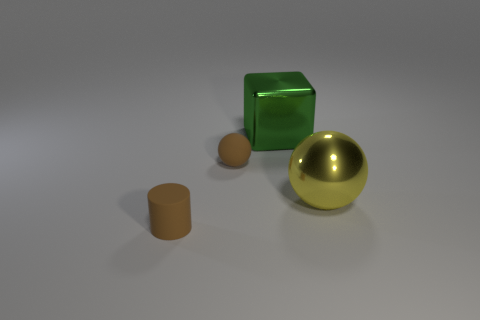What number of things are big metal blocks or objects that are on the right side of the small brown cylinder?
Give a very brief answer. 3. How many small brown matte things are to the left of the large metallic thing that is in front of the large object that is to the left of the big yellow metal thing?
Your answer should be compact. 2. There is a small brown rubber thing that is behind the cylinder; is its shape the same as the green thing?
Your answer should be very brief. No. Are there any metal balls in front of the metallic object in front of the large green cube?
Make the answer very short. No. What number of tiny brown spheres are there?
Keep it short and to the point. 1. There is a object that is on the left side of the big green metallic cube and right of the tiny brown cylinder; what is its color?
Provide a succinct answer. Brown. What size is the rubber thing that is the same shape as the yellow metallic thing?
Your answer should be very brief. Small. How many red rubber objects are the same size as the metal ball?
Your answer should be compact. 0. What material is the tiny sphere?
Your answer should be compact. Rubber. There is a brown ball; are there any big metal cubes in front of it?
Make the answer very short. No. 